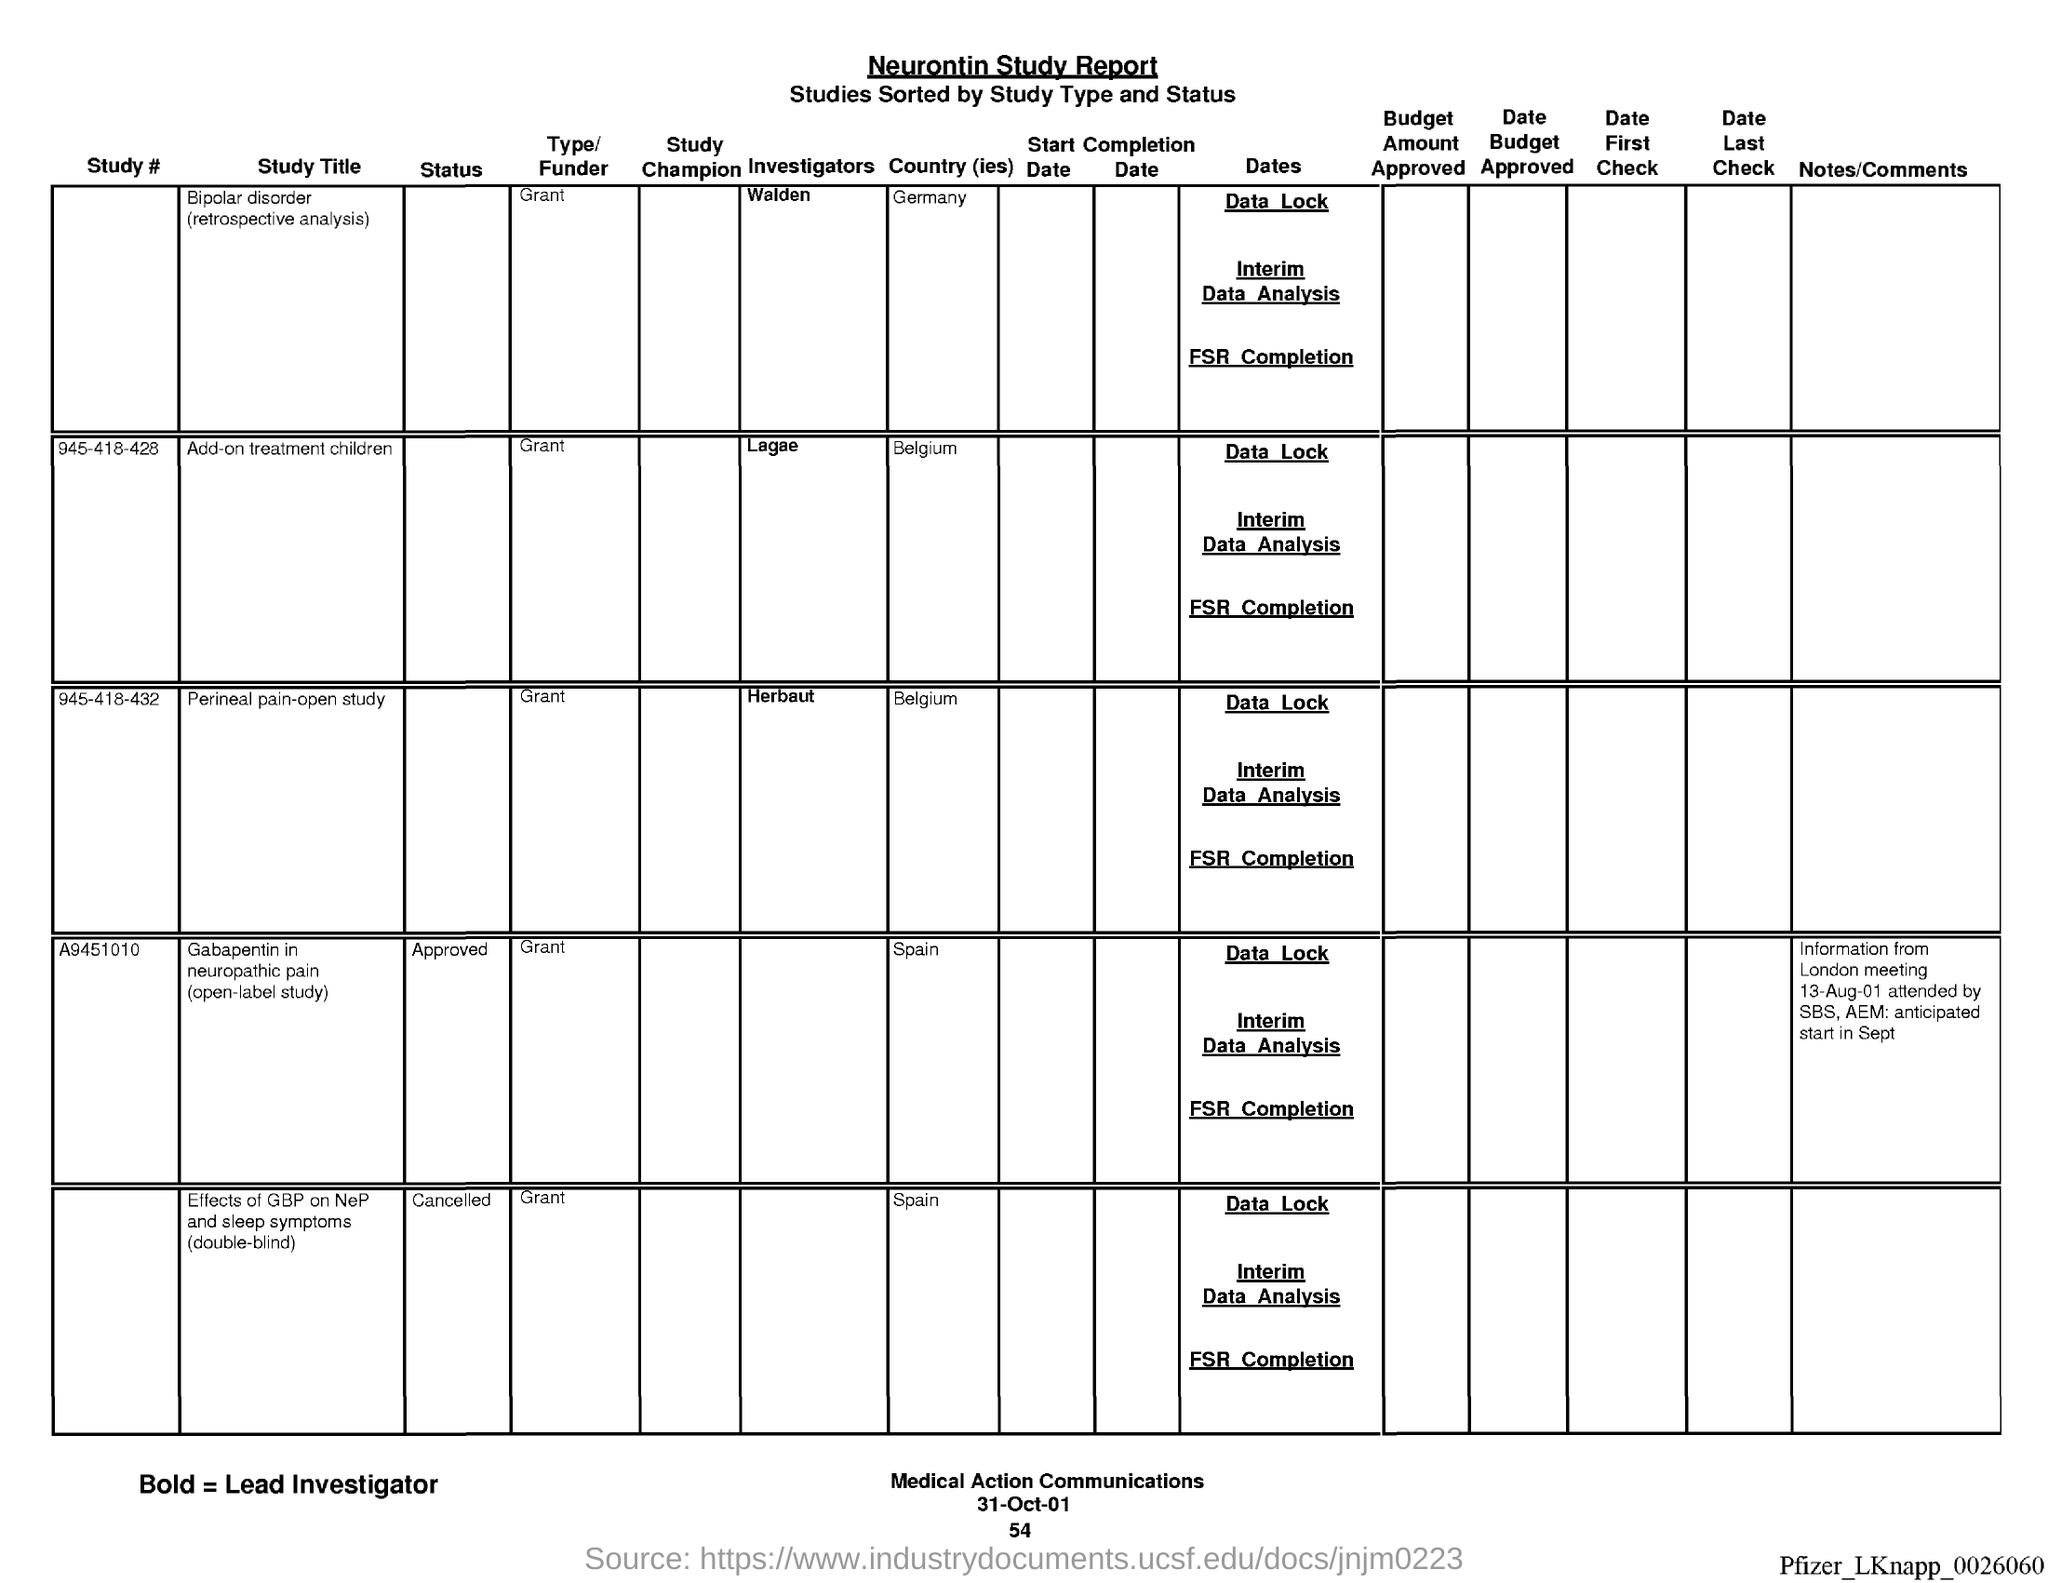Indicate a few pertinent items in this graphic. The page number below the date is 54. The Neurontin Study report is the name of the report. The date at the bottom of the page is 31 October 2001. 